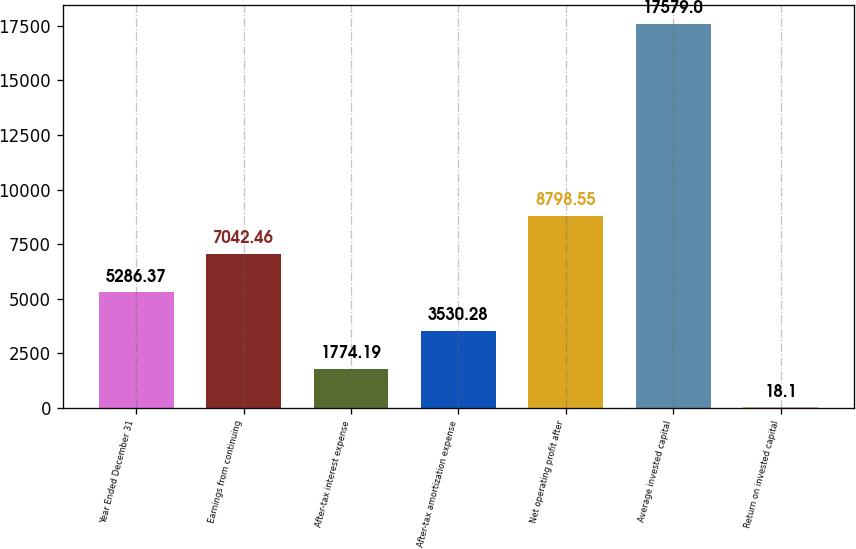Convert chart to OTSL. <chart><loc_0><loc_0><loc_500><loc_500><bar_chart><fcel>Year Ended December 31<fcel>Earnings from continuing<fcel>After-tax interest expense<fcel>After-tax amortization expense<fcel>Net operating profit after<fcel>Average invested capital<fcel>Return on invested capital<nl><fcel>5286.37<fcel>7042.46<fcel>1774.19<fcel>3530.28<fcel>8798.55<fcel>17579<fcel>18.1<nl></chart> 